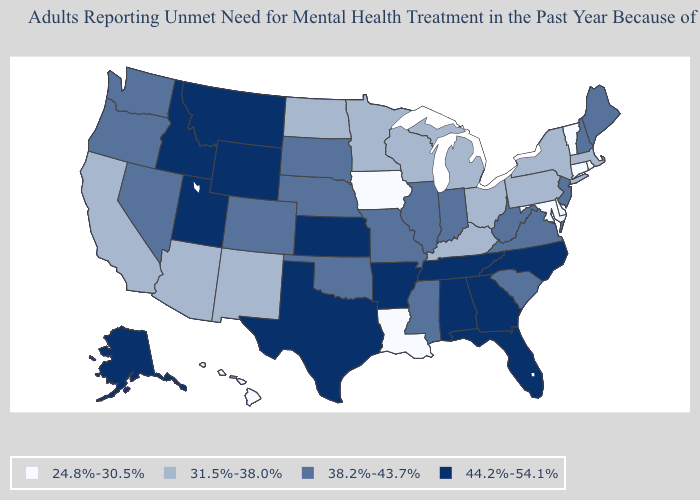What is the value of Illinois?
Write a very short answer. 38.2%-43.7%. Among the states that border Nevada , which have the highest value?
Quick response, please. Idaho, Utah. What is the value of Pennsylvania?
Be succinct. 31.5%-38.0%. Which states have the highest value in the USA?
Short answer required. Alabama, Alaska, Arkansas, Florida, Georgia, Idaho, Kansas, Montana, North Carolina, Tennessee, Texas, Utah, Wyoming. What is the lowest value in the USA?
Keep it brief. 24.8%-30.5%. Name the states that have a value in the range 44.2%-54.1%?
Be succinct. Alabama, Alaska, Arkansas, Florida, Georgia, Idaho, Kansas, Montana, North Carolina, Tennessee, Texas, Utah, Wyoming. Which states have the lowest value in the USA?
Quick response, please. Connecticut, Delaware, Hawaii, Iowa, Louisiana, Maryland, Rhode Island, Vermont. Does the map have missing data?
Answer briefly. No. Name the states that have a value in the range 24.8%-30.5%?
Quick response, please. Connecticut, Delaware, Hawaii, Iowa, Louisiana, Maryland, Rhode Island, Vermont. Which states have the highest value in the USA?
Short answer required. Alabama, Alaska, Arkansas, Florida, Georgia, Idaho, Kansas, Montana, North Carolina, Tennessee, Texas, Utah, Wyoming. What is the lowest value in states that border Louisiana?
Keep it brief. 38.2%-43.7%. What is the value of Pennsylvania?
Short answer required. 31.5%-38.0%. Name the states that have a value in the range 24.8%-30.5%?
Concise answer only. Connecticut, Delaware, Hawaii, Iowa, Louisiana, Maryland, Rhode Island, Vermont. What is the lowest value in the USA?
Answer briefly. 24.8%-30.5%. Does West Virginia have the highest value in the USA?
Short answer required. No. 